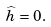Convert formula to latex. <formula><loc_0><loc_0><loc_500><loc_500>\widehat { h } = 0 .</formula> 